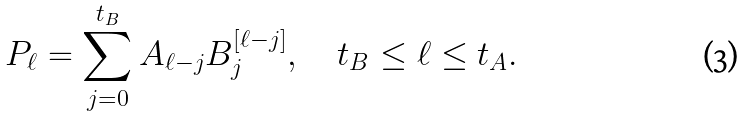<formula> <loc_0><loc_0><loc_500><loc_500>P _ { \ell } = \sum _ { j = 0 } ^ { t _ { B } } A _ { \ell - j } B _ { j } ^ { [ \ell - j ] } , \quad t _ { B } \leq \ell \leq t _ { A } .</formula> 